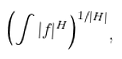Convert formula to latex. <formula><loc_0><loc_0><loc_500><loc_500>\left ( \int | f | ^ { H } \right ) ^ { 1 / | H | } ,</formula> 